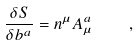Convert formula to latex. <formula><loc_0><loc_0><loc_500><loc_500>\frac { \delta S } { \delta b ^ { a } } = n ^ { \mu } A ^ { a } _ { \mu } \quad ,</formula> 